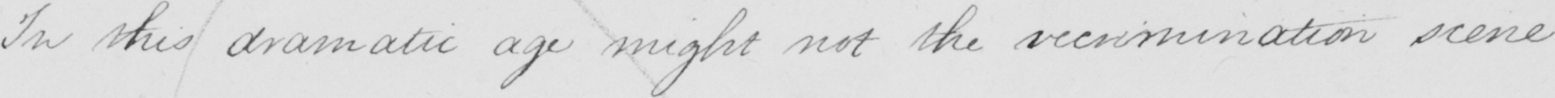What is written in this line of handwriting? In this dramatic age might not the recrimination scene 